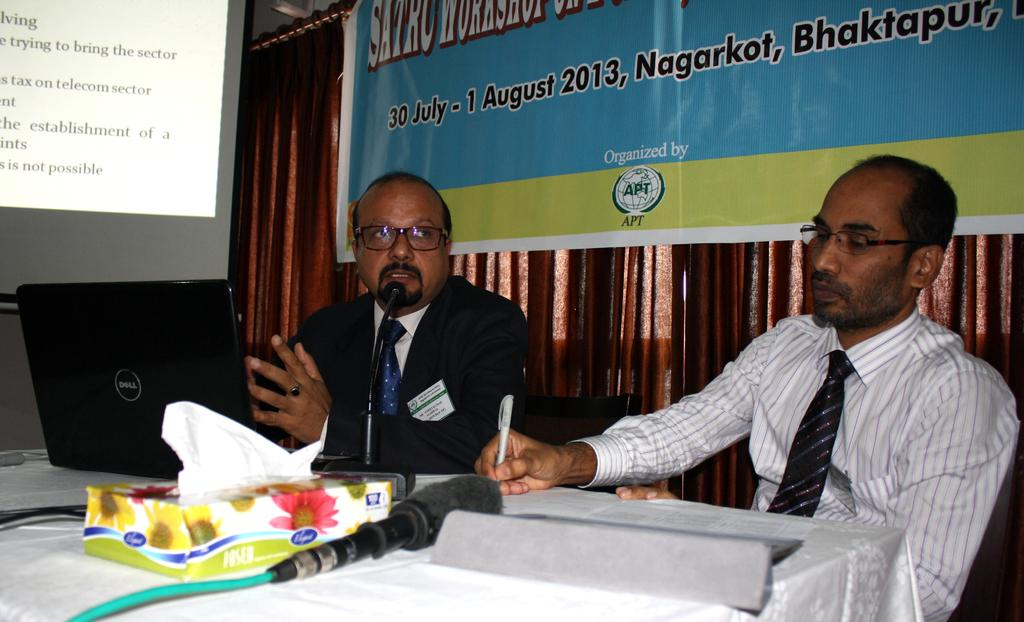How many people are sitting in the image? There are two men sitting on chairs in the image. What is on the table in the image? There is a black laptop and a microphone on the table in the image. What can be seen in the background of the image? There is a brown color curtain and a blue banner in the background. How many balls are visible in the image? There are no balls present in the image. Is there a duck sitting with the two men in the image? There is no duck present in the image. 